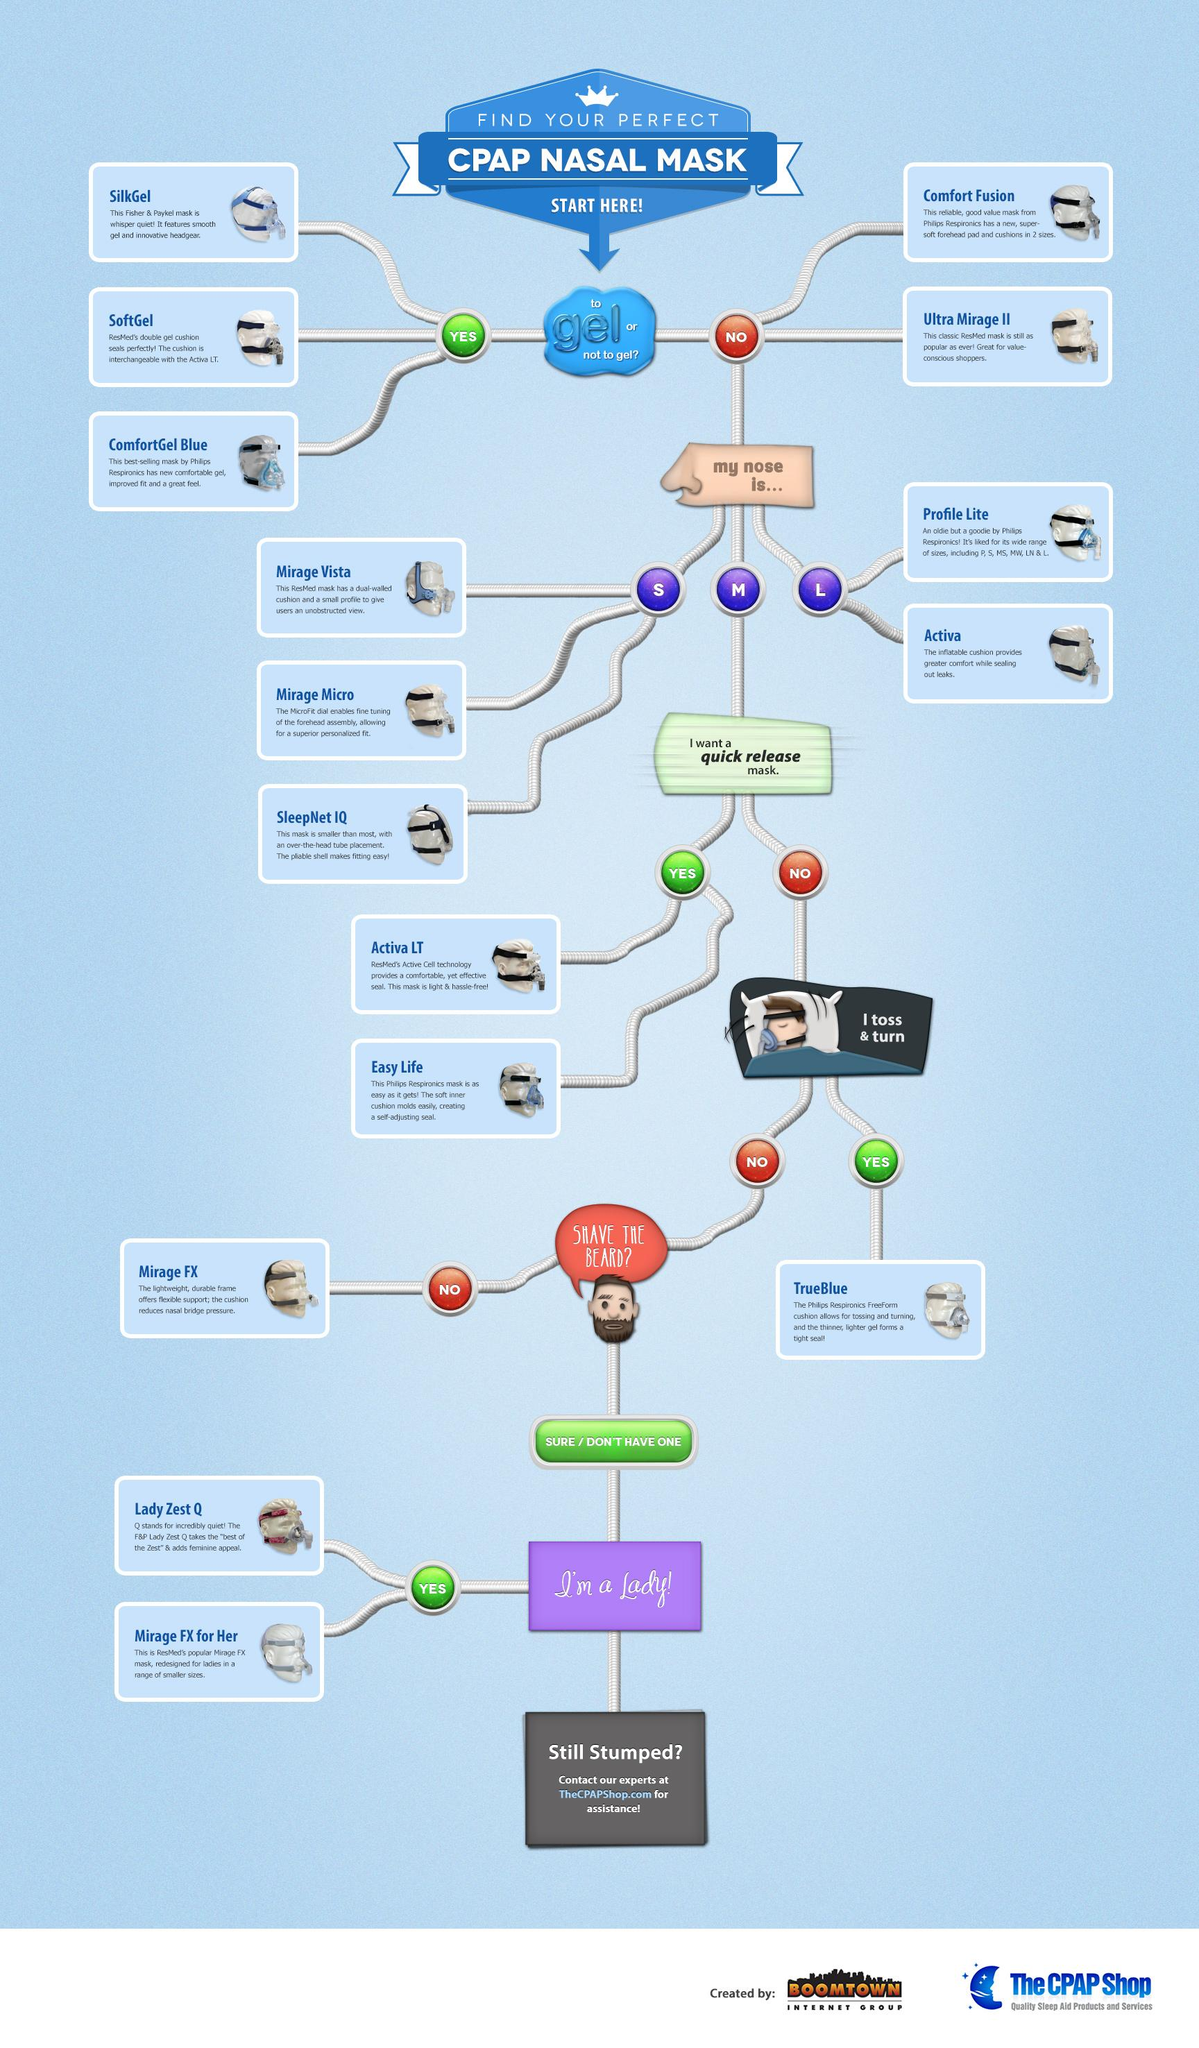Draw attention to some important aspects in this diagram. SleepNet IQ is the mask listed in the infographic that is smaller than most. There are three options available for a CPAP Nasal Mask with gel. The Mirage FX mask is the best choice for bearded individuals, according to the infographic. The infographic indicates that the Lady Zest Q and Mirage FX masks are intended for women. TrueBlue is the best mask for people who toss and turn while asleep as it effectively reduces snoring and provides optimal comfort throughout the night. 